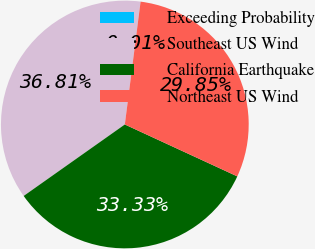Convert chart. <chart><loc_0><loc_0><loc_500><loc_500><pie_chart><fcel>Exceeding Probability<fcel>Southeast US Wind<fcel>California Earthquake<fcel>Northeast US Wind<nl><fcel>0.01%<fcel>36.81%<fcel>33.33%<fcel>29.85%<nl></chart> 